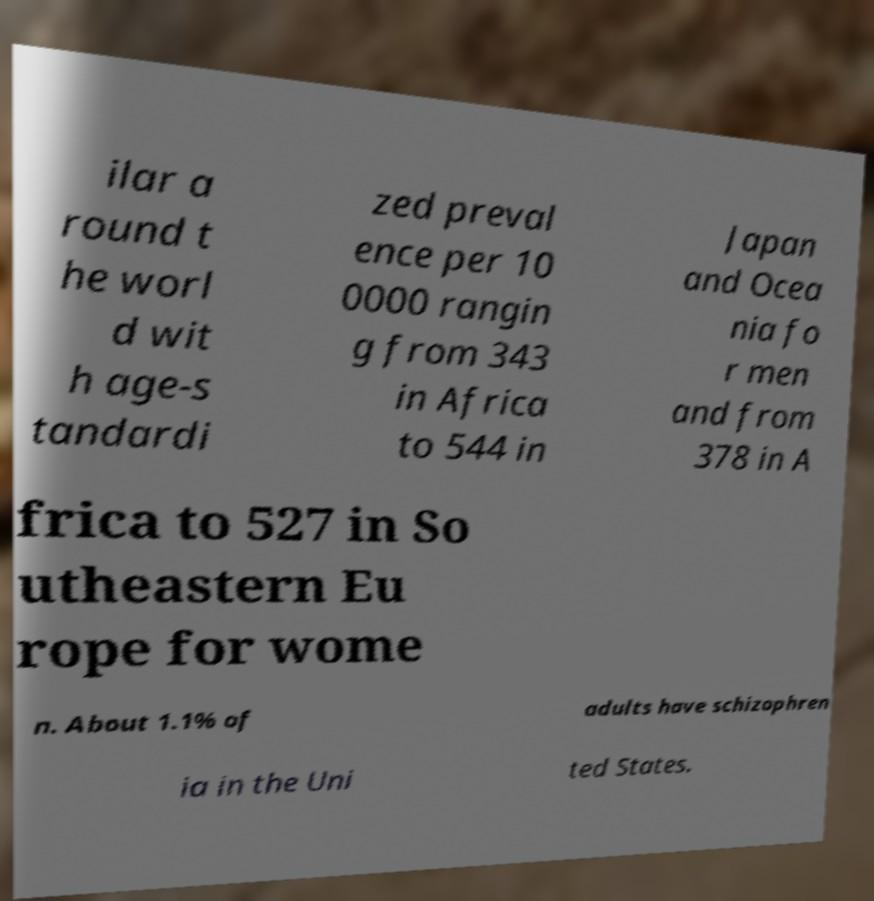Please identify and transcribe the text found in this image. ilar a round t he worl d wit h age-s tandardi zed preval ence per 10 0000 rangin g from 343 in Africa to 544 in Japan and Ocea nia fo r men and from 378 in A frica to 527 in So utheastern Eu rope for wome n. About 1.1% of adults have schizophren ia in the Uni ted States. 